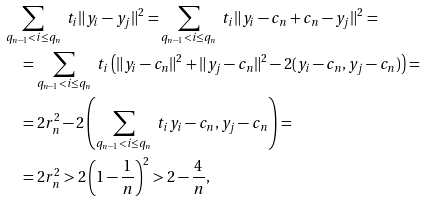<formula> <loc_0><loc_0><loc_500><loc_500>& \sum _ { q _ { n - 1 } < i \leq q _ { n } } \ t _ { i } \| y _ { i } - y _ { j } \| ^ { 2 } = \sum _ { q _ { n - 1 } < i \leq q _ { n } } \ t _ { i } \| y _ { i } - c _ { n } + c _ { n } - y _ { j } \| ^ { 2 } = \\ & { \quad } = \sum _ { q _ { n - 1 } < i \leq q _ { n } } \ t _ { i } \left ( \| y _ { i } - c _ { n } \| ^ { 2 } + \| y _ { j } - c _ { n } \| ^ { 2 } - 2 ( y _ { i } - c _ { n } , y _ { j } - c _ { n } ) \right ) = \\ & { \quad } = 2 r _ { n } ^ { 2 } - 2 \left ( \sum _ { q _ { n - 1 } < i \leq q _ { n } } \ t _ { i } y _ { i } - c _ { n } , y _ { j } - c _ { n } \right ) = \\ & { \quad } = 2 r _ { n } ^ { 2 } > 2 \left ( 1 - \frac { 1 } { n } \right ) ^ { 2 } > 2 - \frac { 4 } { n } ,</formula> 